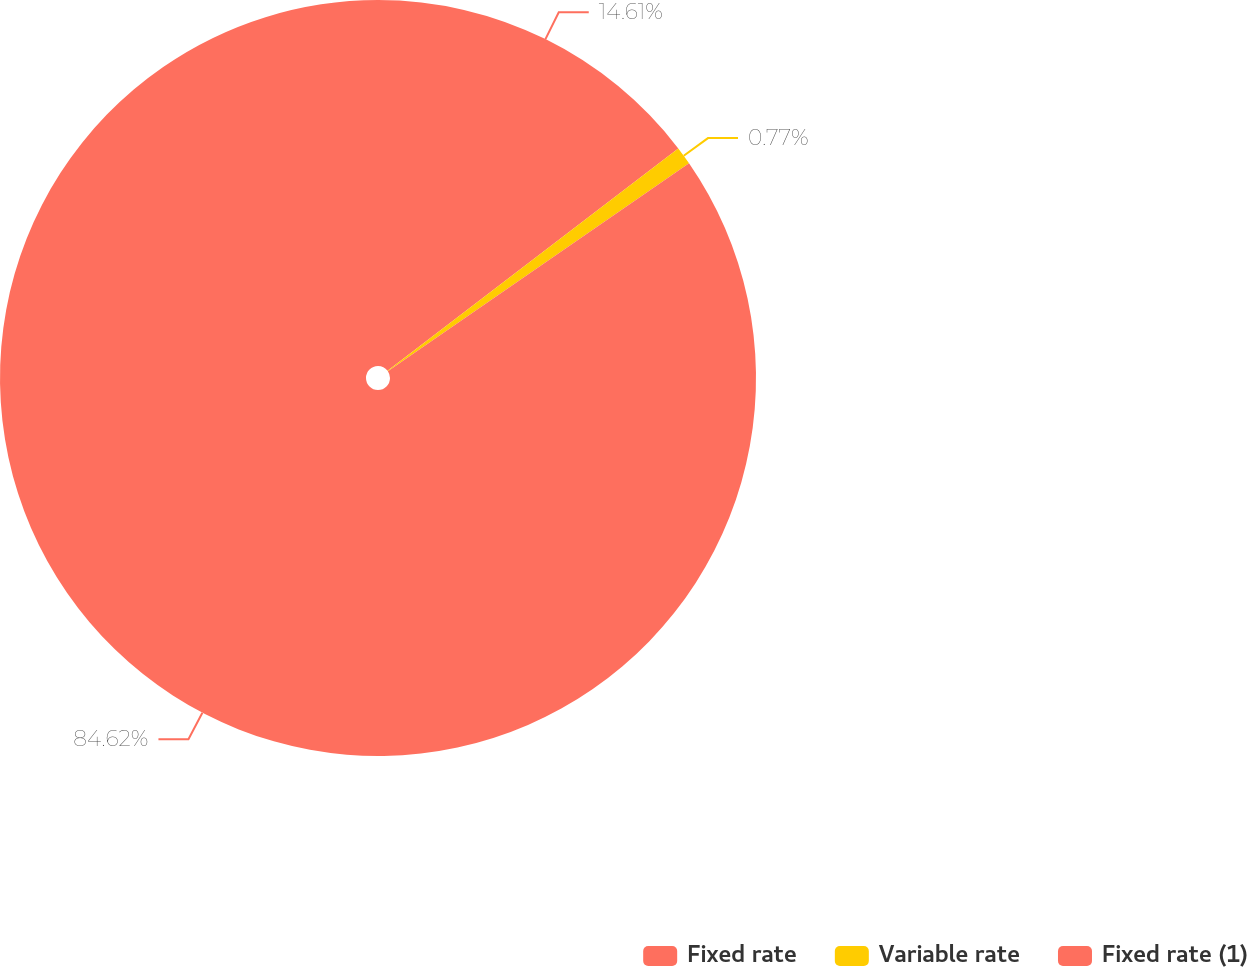<chart> <loc_0><loc_0><loc_500><loc_500><pie_chart><fcel>Fixed rate<fcel>Variable rate<fcel>Fixed rate (1)<nl><fcel>14.61%<fcel>0.77%<fcel>84.62%<nl></chart> 